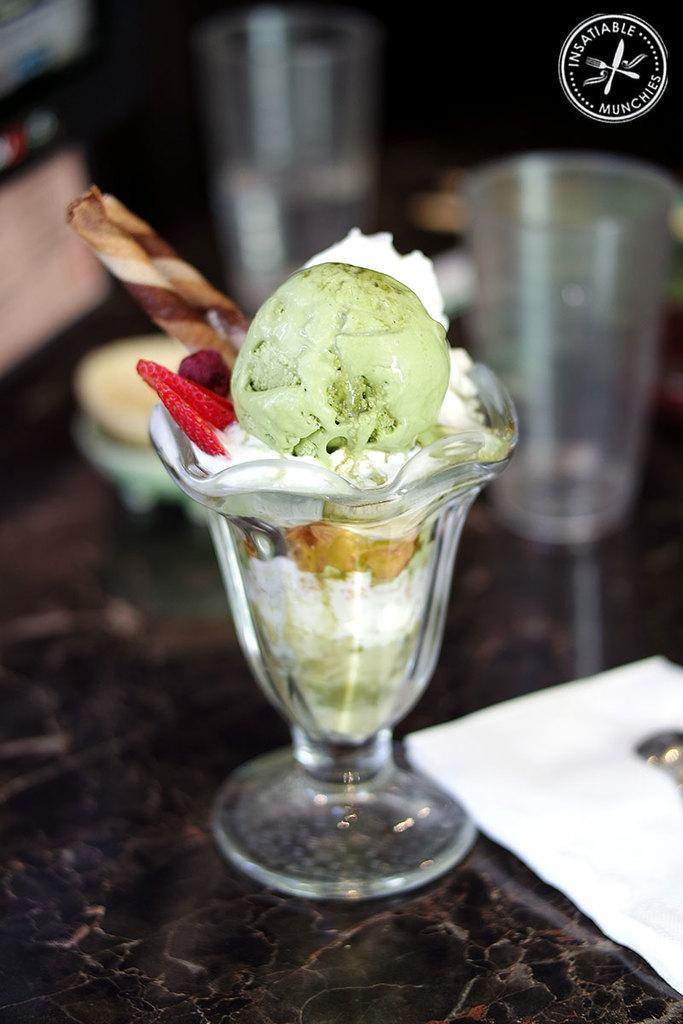What type of container is the ice-cream in? The ice-cream is in a glass jar. What else can be seen on the right side of the image? There is a glass on the right side of the image. How many people are jumping in the image? There are no people visible in the image, so it is not possible to determine how many people might be jumping. 